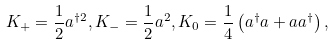Convert formula to latex. <formula><loc_0><loc_0><loc_500><loc_500>K _ { + } = \frac { 1 } { 2 } a ^ { \dagger 2 } , K _ { - } = \frac { 1 } { 2 } a ^ { 2 } , K _ { 0 } = \frac { 1 } { 4 } \left ( a ^ { \dagger } a + a a ^ { \dagger } \right ) ,</formula> 